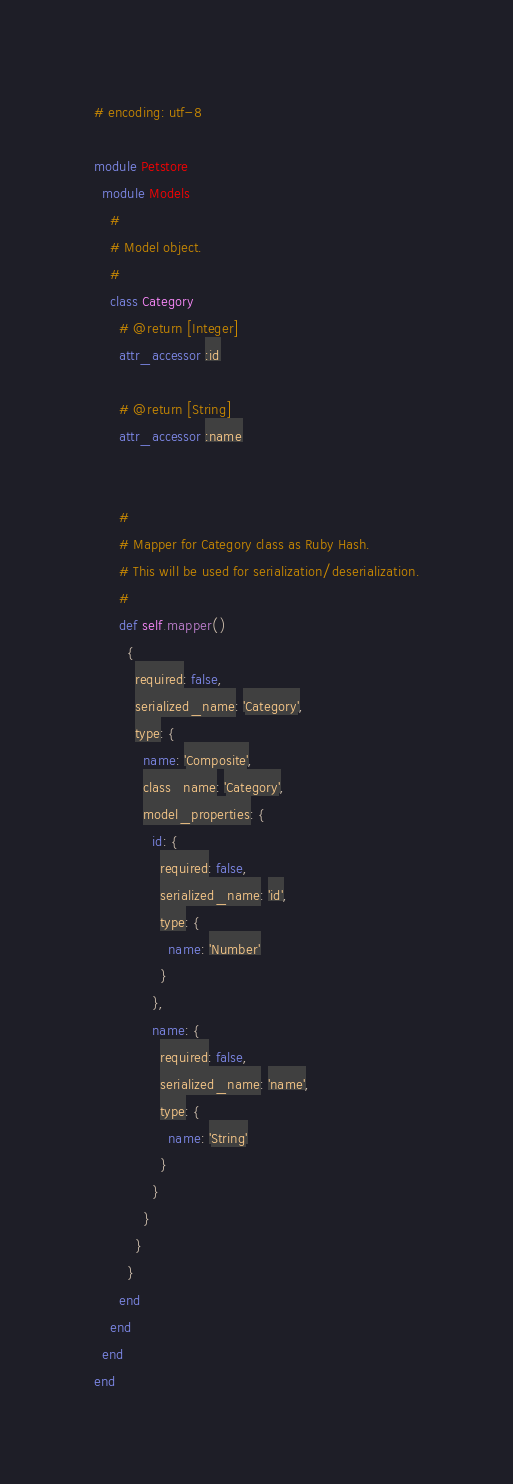<code> <loc_0><loc_0><loc_500><loc_500><_Ruby_># encoding: utf-8

module Petstore
  module Models
    #
    # Model object.
    #
    class Category
      # @return [Integer]
      attr_accessor :id

      # @return [String]
      attr_accessor :name


      #
      # Mapper for Category class as Ruby Hash.
      # This will be used for serialization/deserialization.
      #
      def self.mapper()
        {
          required: false,
          serialized_name: 'Category',
          type: {
            name: 'Composite',
            class_name: 'Category',
            model_properties: {
              id: {
                required: false,
                serialized_name: 'id',
                type: {
                  name: 'Number'
                }
              },
              name: {
                required: false,
                serialized_name: 'name',
                type: {
                  name: 'String'
                }
              }
            }
          }
        }
      end
    end
  end
end
</code> 